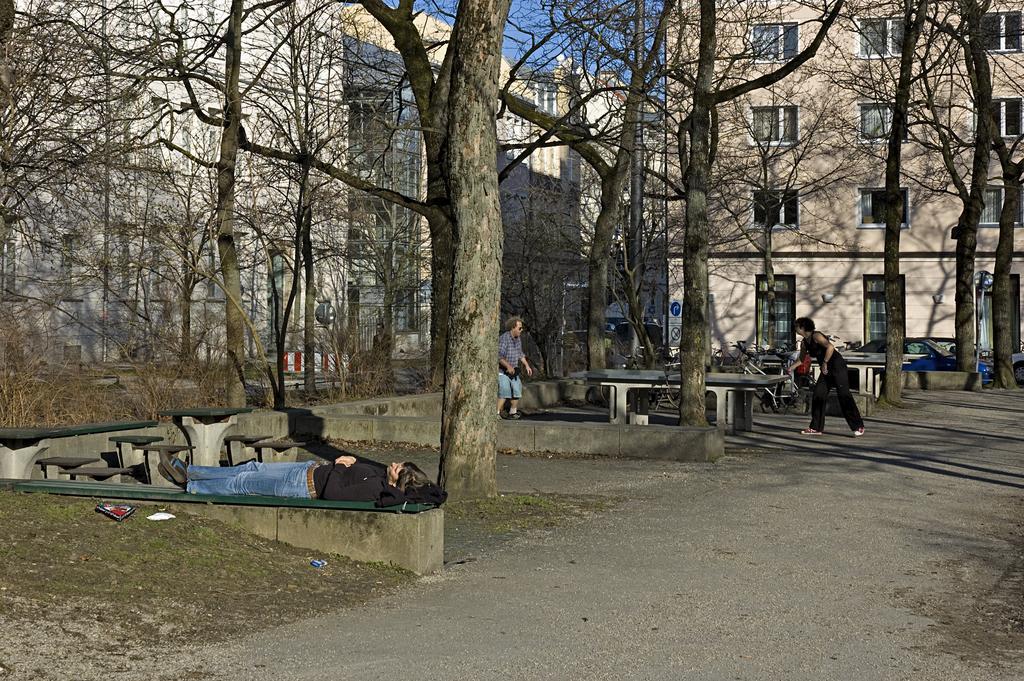How would you summarize this image in a sentence or two? In this image I can see a person sleeping on the bench, background I can see two other persons playing game, dried trees, buildings in cream and white color and sky in blue color. 